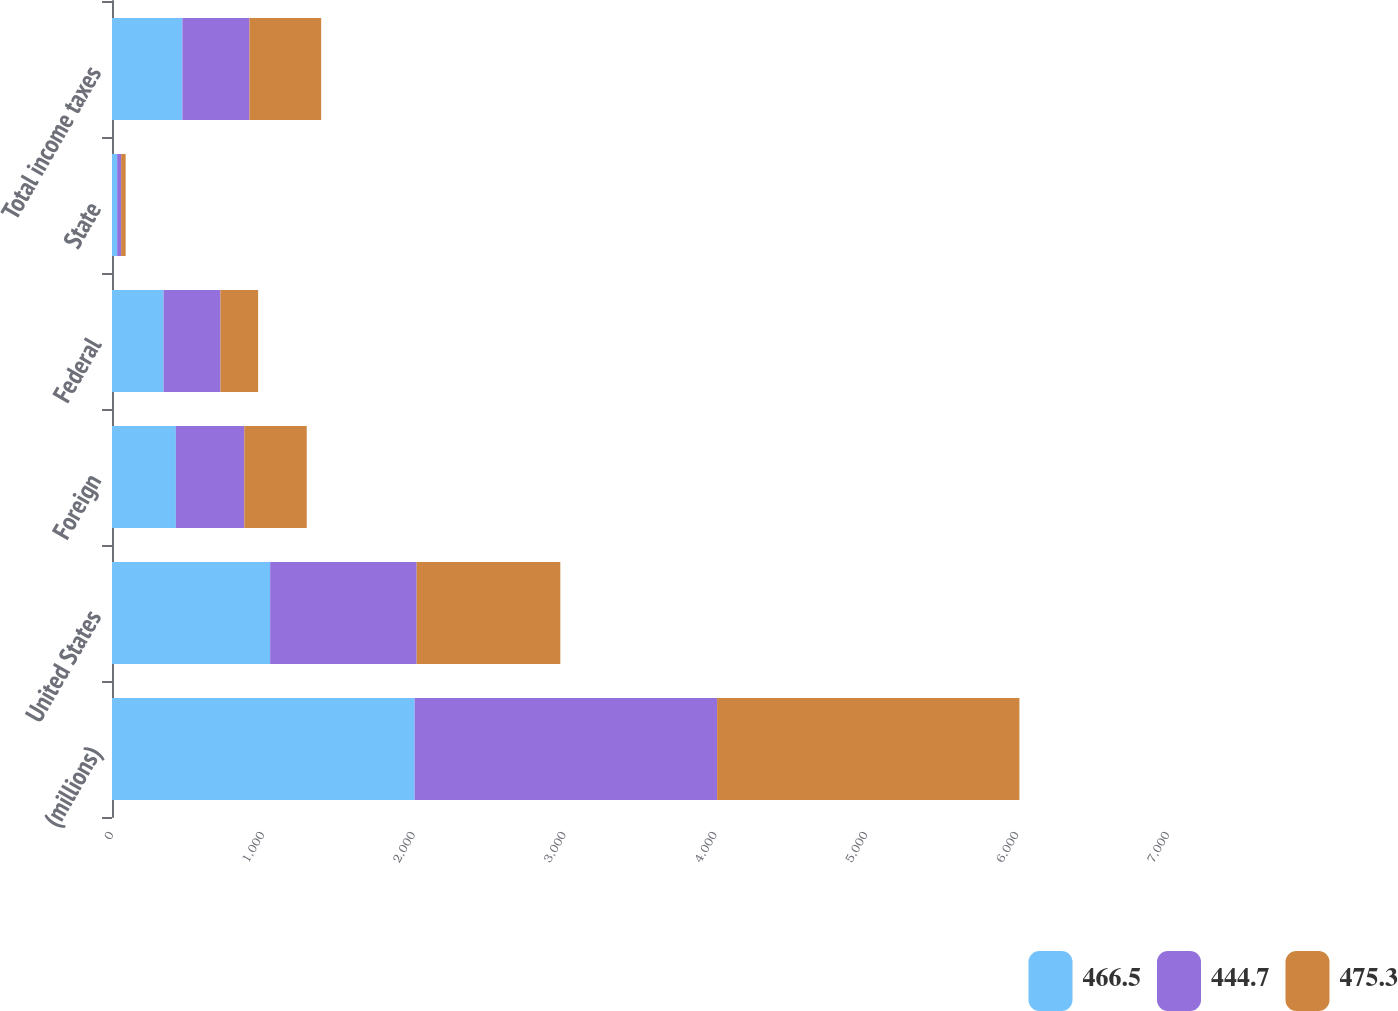Convert chart to OTSL. <chart><loc_0><loc_0><loc_500><loc_500><stacked_bar_chart><ecel><fcel>(millions)<fcel>United States<fcel>Foreign<fcel>Federal<fcel>State<fcel>Total income taxes<nl><fcel>466.5<fcel>2006<fcel>1048.3<fcel>423.3<fcel>342<fcel>34.1<fcel>466.5<nl><fcel>444.7<fcel>2005<fcel>971.4<fcel>453.7<fcel>376.8<fcel>26.4<fcel>444.7<nl><fcel>475.3<fcel>2004<fcel>952<fcel>413.9<fcel>249.8<fcel>30<fcel>475.3<nl></chart> 